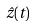<formula> <loc_0><loc_0><loc_500><loc_500>\hat { z } ( t )</formula> 